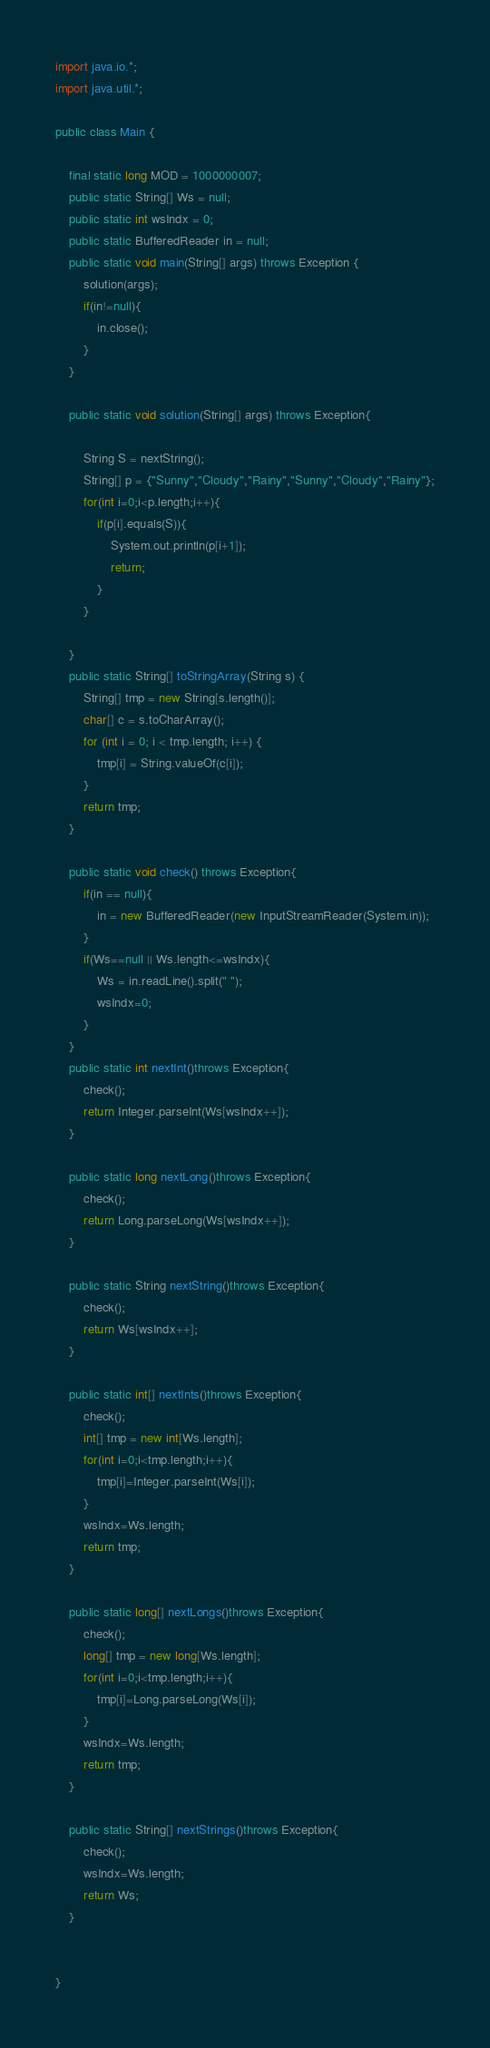Convert code to text. <code><loc_0><loc_0><loc_500><loc_500><_Java_>import java.io.*;
import java.util.*;

public class Main {

	final static long MOD = 1000000007;
	public static String[] Ws = null;
	public static int wsIndx = 0;
	public static BufferedReader in = null;
	public static void main(String[] args) throws Exception {
		solution(args);
		if(in!=null){
			in.close();
		}
	}

	public static void solution(String[] args) throws Exception{

		String S = nextString();
		String[] p = {"Sunny","Cloudy","Rainy","Sunny","Cloudy","Rainy"};
		for(int i=0;i<p.length;i++){
			if(p[i].equals(S)){
				System.out.println(p[i+1]);
				return;
			}
		}

	}
	public static String[] toStringArray(String s) {
		String[] tmp = new String[s.length()];
		char[] c = s.toCharArray();
		for (int i = 0; i < tmp.length; i++) {
			tmp[i] = String.valueOf(c[i]);
		}
		return tmp;
	}

	public static void check() throws Exception{
		if(in == null){
			in = new BufferedReader(new InputStreamReader(System.in));
		}
		if(Ws==null || Ws.length<=wsIndx){
			Ws = in.readLine().split(" ");
			wsIndx=0;
		}
	}
	public static int nextInt()throws Exception{
		check();
		return Integer.parseInt(Ws[wsIndx++]);
	}

	public static long nextLong()throws Exception{
		check();
		return Long.parseLong(Ws[wsIndx++]);
	}

	public static String nextString()throws Exception{
		check();
		return Ws[wsIndx++];
	}

	public static int[] nextInts()throws Exception{
		check();
		int[] tmp = new int[Ws.length];
		for(int i=0;i<tmp.length;i++){
			tmp[i]=Integer.parseInt(Ws[i]);
		}
		wsIndx=Ws.length;
		return tmp;
	}

	public static long[] nextLongs()throws Exception{
		check();
		long[] tmp = new long[Ws.length];
		for(int i=0;i<tmp.length;i++){
			tmp[i]=Long.parseLong(Ws[i]);
		}
		wsIndx=Ws.length;
		return tmp;
	}

	public static String[] nextStrings()throws Exception{
		check();
		wsIndx=Ws.length;
		return Ws;
	}


}
</code> 